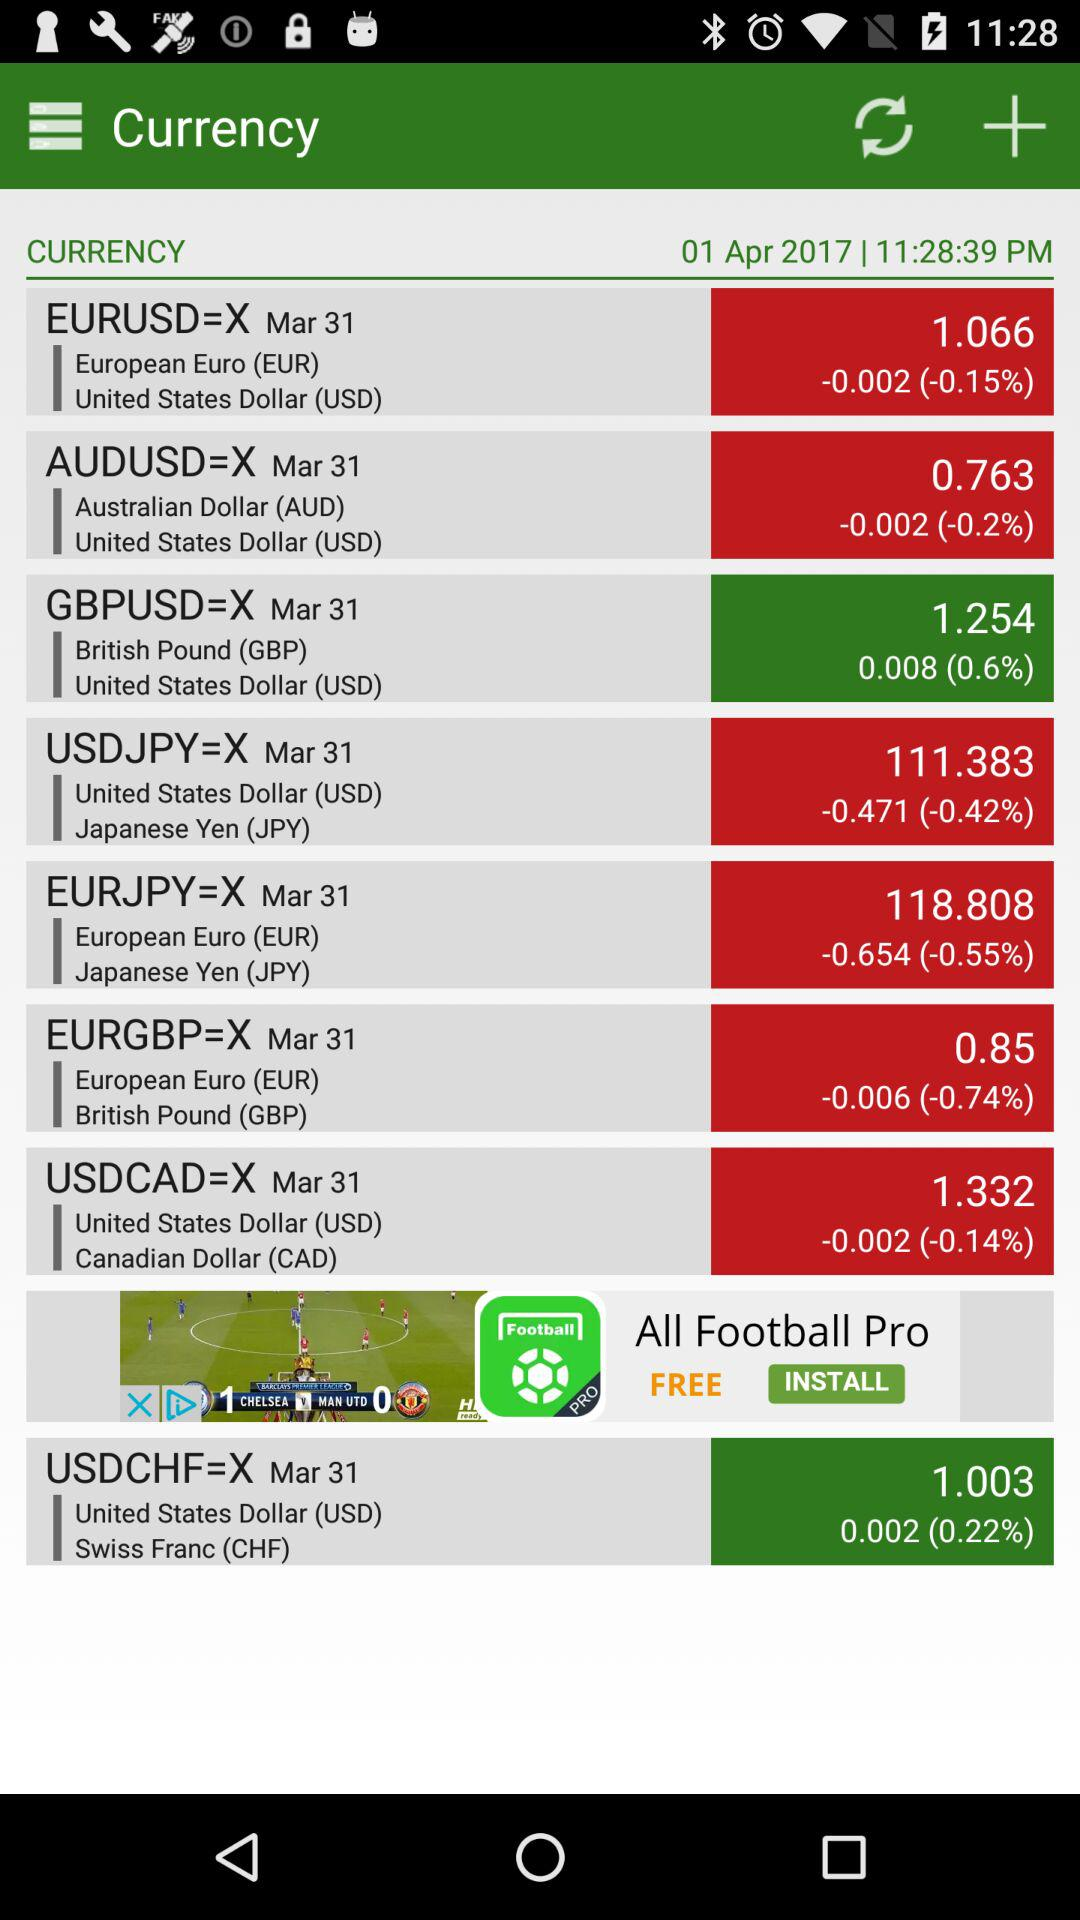What is the current exchange rate between the euro and the Canadian Dollar?
When the provided information is insufficient, respond with <no answer>. <no answer> 